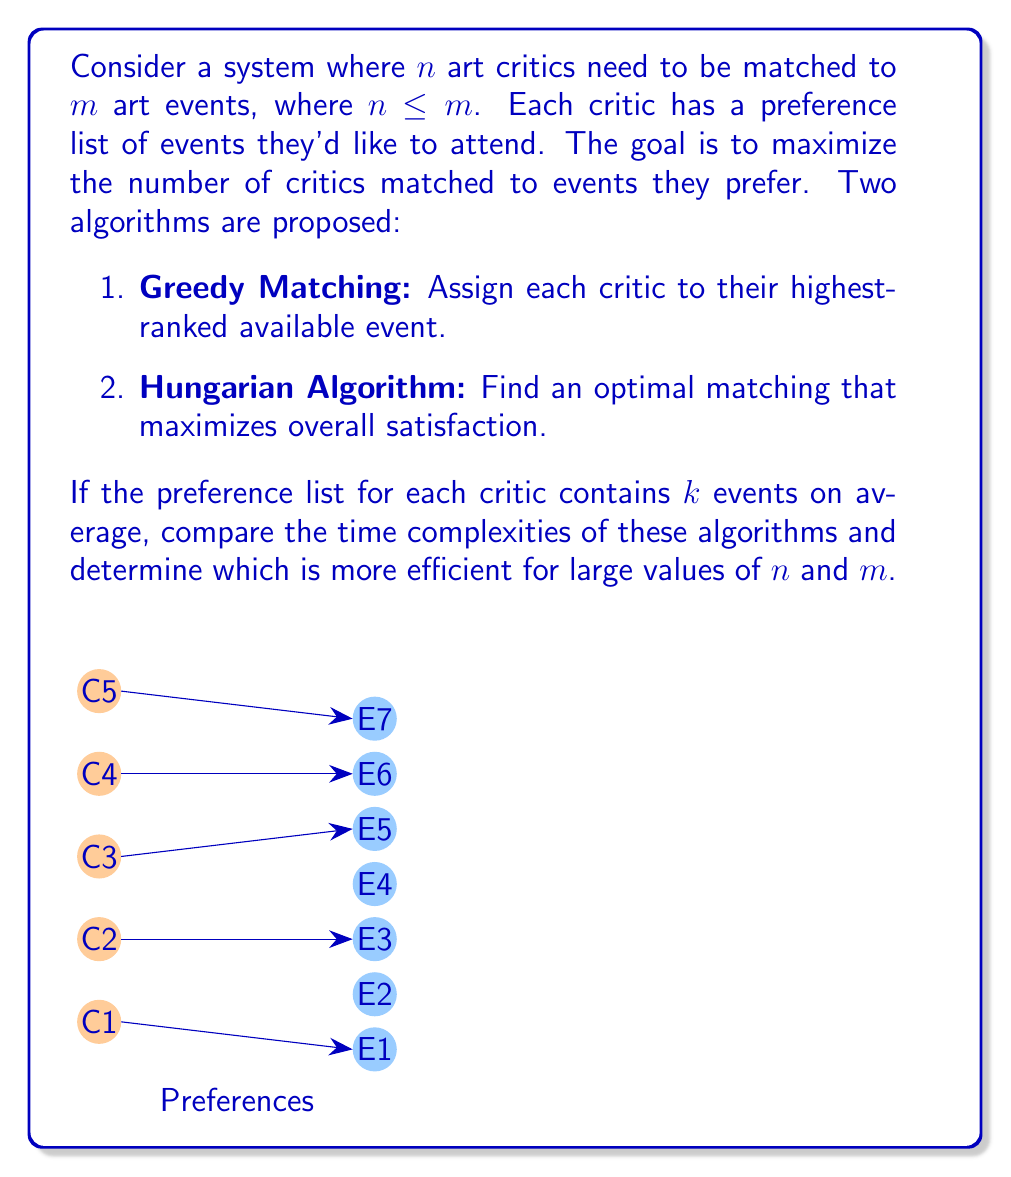Can you solve this math problem? Let's analyze the time complexities of both algorithms:

1. Greedy Matching:
   - For each critic, we need to find the highest-ranked available event.
   - This requires scanning through the preference list of length $k$ for each of the $n$ critics.
   - Time complexity: $O(nk)$

2. Hungarian Algorithm:
   - The Hungarian algorithm has a time complexity of $O(n^3)$ for an $n \times n$ matrix.
   - In our case, we have an $n \times m$ matrix, where $n \leq m$.
   - The time complexity becomes $O(n^2m)$.

To compare:
- Greedy Matching: $O(nk)$
- Hungarian Algorithm: $O(n^2m)$

For large values of $n$ and $m$:
- If $k$ is significantly smaller than $n$ and $m$ (which is often the case in real-world scenarios where critics have a limited number of preferred events), the Greedy Matching algorithm will be more efficient.
- The Hungarian Algorithm's complexity grows quadratically with $n$ and linearly with $m$, making it less efficient for large datasets.

However, it's important to note that while the Greedy Matching algorithm is more computationally efficient, it may not always produce the optimal matching. The Hungarian Algorithm guarantees an optimal solution but at a higher computational cost.

In the context of a journalist deciding which events to prioritize, the Greedy Matching algorithm might be preferred due to its efficiency, especially when dealing with a large number of critics and events. This aligns with the need to make quick decisions about event coverage in a fast-paced journalistic environment.
Answer: Greedy Matching: $O(nk)$, more efficient for large $n$ and $m$ when $k \ll n,m$. 